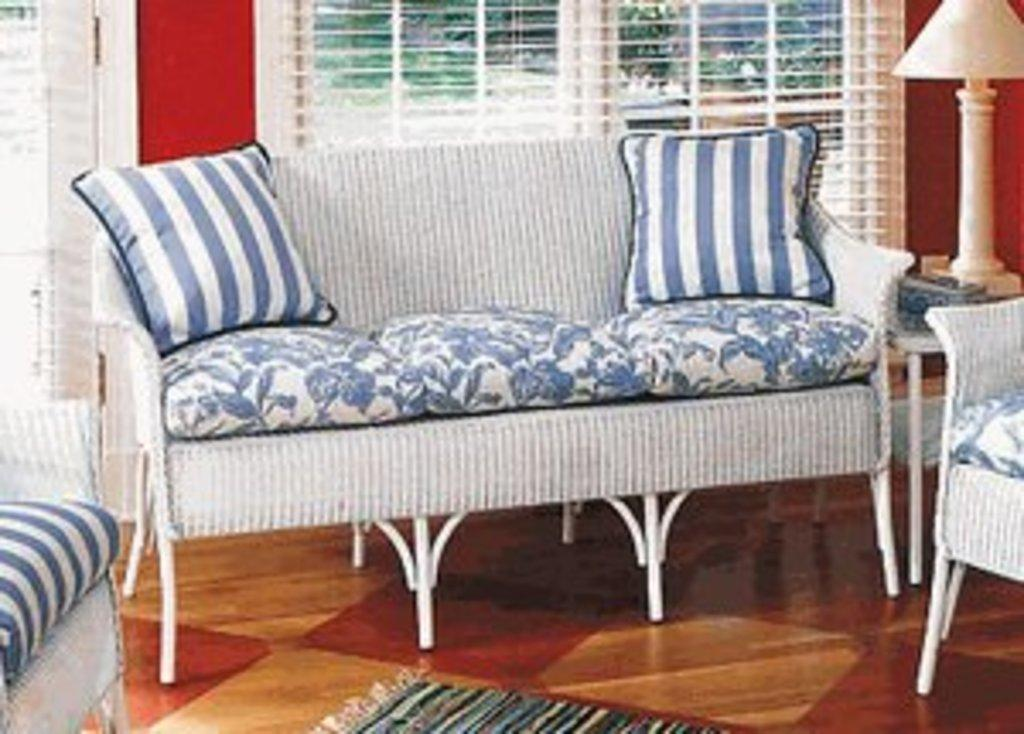What type of furniture is present in the image? There is a sofa in the image. Where is the sofa located? The sofa is in a house. What can be seen in the background of the image? There are trees visible in the background of the image. What type of income does the person sitting on the sofa earn? There is no person sitting on the sofa in the image, and therefore no information about their income can be determined. 